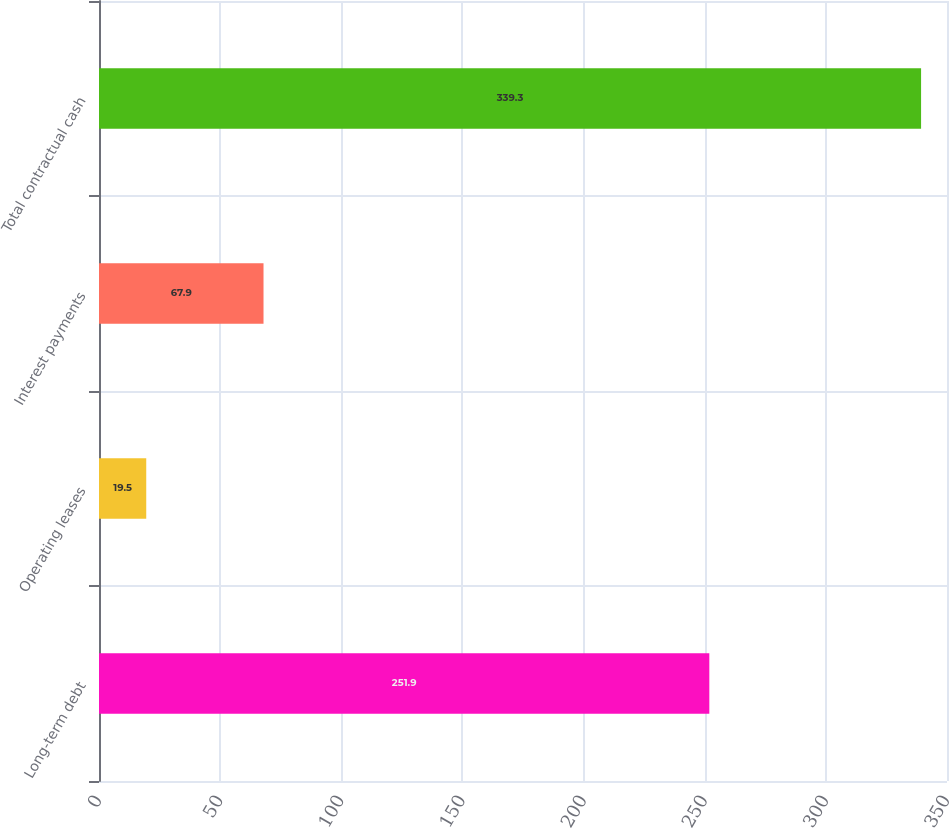<chart> <loc_0><loc_0><loc_500><loc_500><bar_chart><fcel>Long-term debt<fcel>Operating leases<fcel>Interest payments<fcel>Total contractual cash<nl><fcel>251.9<fcel>19.5<fcel>67.9<fcel>339.3<nl></chart> 